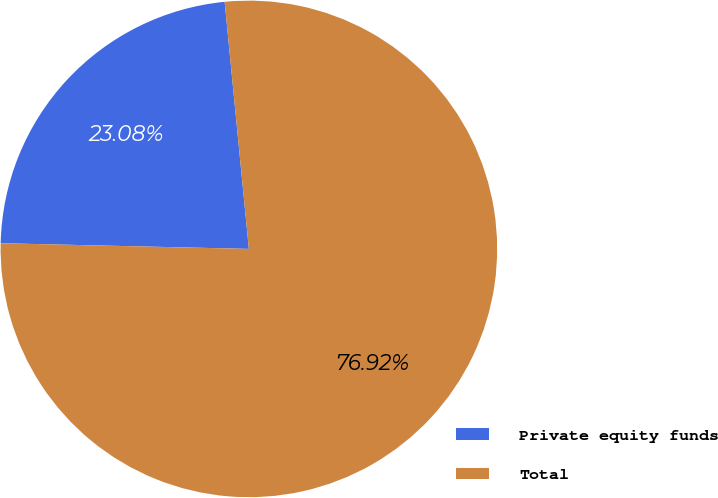Convert chart. <chart><loc_0><loc_0><loc_500><loc_500><pie_chart><fcel>Private equity funds<fcel>Total<nl><fcel>23.08%<fcel>76.92%<nl></chart> 